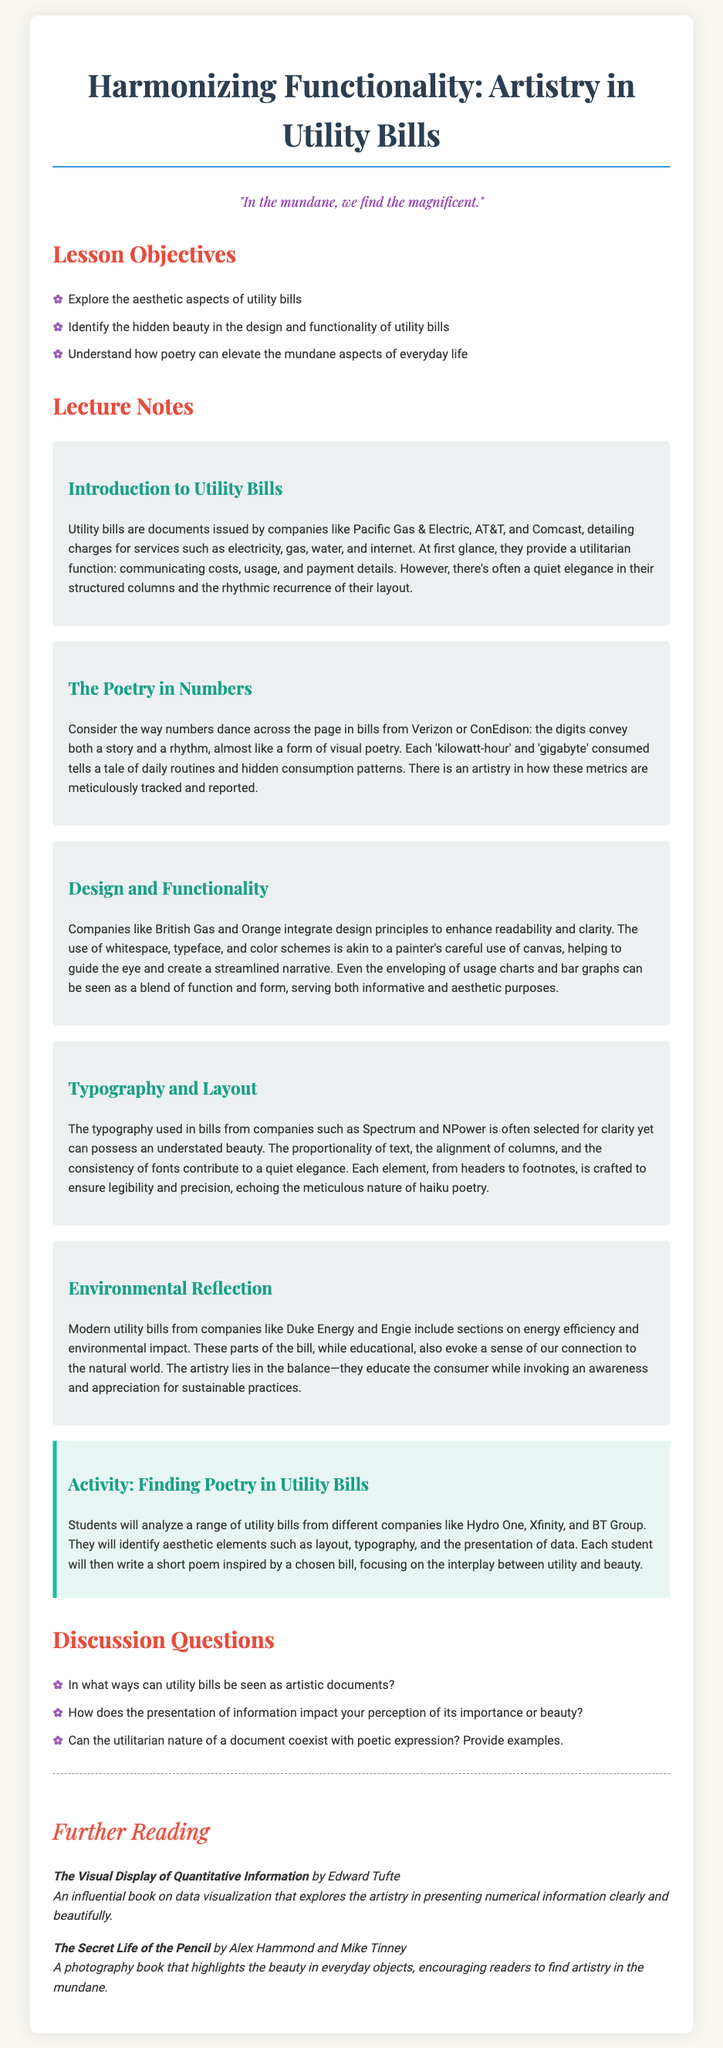what is the title of the lesson plan? The title of the lesson plan is stated at the top of the document.
Answer: Harmonizing Functionality: Artistry in Utility Bills who is the author of the quote in the lesson plan? The quote is included in the lesson plan, but it does not specify an author.
Answer: Not specified how many main sections are there in the lecture notes? The lecture notes are divided into several sections, and counting them gives the number of main sections.
Answer: 5 what activity are students required to do? The activity section outlines a specific task students will undertake during the lesson.
Answer: Finding Poetry in Utility Bills which company is mentioned as an example in the Environmental Reflection section? The Environmental Reflection section specifically lists a company as an example of modern utility bills.
Answer: Duke Energy what is one of the objectives of the lesson? The lesson objectives outline what students will explore concerning utility bills.
Answer: Identify the hidden beauty in the design and functionality of utility bills how are utility bills described in the context of art? The document provides language that frames utility bills in a unique artistic perspective.
Answer: Artistic documents what type of typography is typically used in utility bills? The Typography and Layout section explains the craftsmanship involved in typographic choices.
Answer: Clarity name one of the further reading titles suggested in the lesson plan. The Further Reading section provides specific book titles for additional exploration.
Answer: The Visual Display of Quantitative Information 